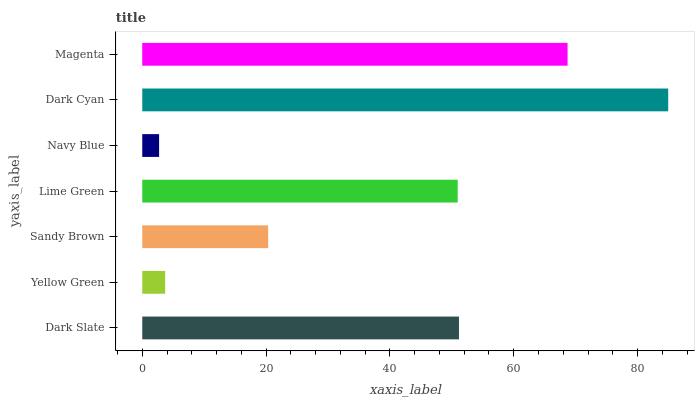Is Navy Blue the minimum?
Answer yes or no. Yes. Is Dark Cyan the maximum?
Answer yes or no. Yes. Is Yellow Green the minimum?
Answer yes or no. No. Is Yellow Green the maximum?
Answer yes or no. No. Is Dark Slate greater than Yellow Green?
Answer yes or no. Yes. Is Yellow Green less than Dark Slate?
Answer yes or no. Yes. Is Yellow Green greater than Dark Slate?
Answer yes or no. No. Is Dark Slate less than Yellow Green?
Answer yes or no. No. Is Lime Green the high median?
Answer yes or no. Yes. Is Lime Green the low median?
Answer yes or no. Yes. Is Sandy Brown the high median?
Answer yes or no. No. Is Navy Blue the low median?
Answer yes or no. No. 